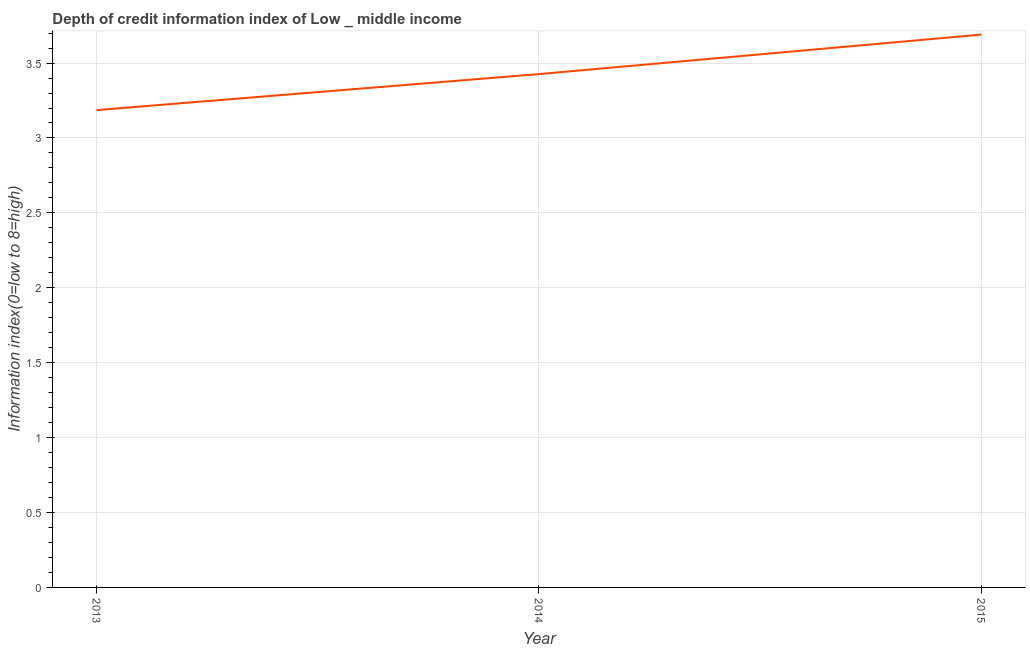What is the depth of credit information index in 2013?
Your answer should be compact. 3.19. Across all years, what is the maximum depth of credit information index?
Offer a very short reply. 3.69. Across all years, what is the minimum depth of credit information index?
Offer a very short reply. 3.19. In which year was the depth of credit information index maximum?
Offer a very short reply. 2015. What is the sum of the depth of credit information index?
Offer a very short reply. 10.3. What is the difference between the depth of credit information index in 2013 and 2015?
Offer a terse response. -0.5. What is the average depth of credit information index per year?
Give a very brief answer. 3.43. What is the median depth of credit information index?
Provide a short and direct response. 3.43. In how many years, is the depth of credit information index greater than 3.4 ?
Provide a short and direct response. 2. What is the ratio of the depth of credit information index in 2013 to that in 2014?
Your answer should be very brief. 0.93. Is the depth of credit information index in 2013 less than that in 2015?
Provide a short and direct response. Yes. What is the difference between the highest and the second highest depth of credit information index?
Offer a terse response. 0.26. What is the difference between the highest and the lowest depth of credit information index?
Provide a short and direct response. 0.5. In how many years, is the depth of credit information index greater than the average depth of credit information index taken over all years?
Provide a short and direct response. 1. What is the difference between two consecutive major ticks on the Y-axis?
Ensure brevity in your answer.  0.5. Are the values on the major ticks of Y-axis written in scientific E-notation?
Provide a succinct answer. No. Does the graph contain any zero values?
Offer a very short reply. No. Does the graph contain grids?
Your response must be concise. Yes. What is the title of the graph?
Your response must be concise. Depth of credit information index of Low _ middle income. What is the label or title of the X-axis?
Provide a succinct answer. Year. What is the label or title of the Y-axis?
Ensure brevity in your answer.  Information index(0=low to 8=high). What is the Information index(0=low to 8=high) of 2013?
Keep it short and to the point. 3.19. What is the Information index(0=low to 8=high) in 2014?
Give a very brief answer. 3.43. What is the Information index(0=low to 8=high) of 2015?
Provide a short and direct response. 3.69. What is the difference between the Information index(0=low to 8=high) in 2013 and 2014?
Keep it short and to the point. -0.24. What is the difference between the Information index(0=low to 8=high) in 2013 and 2015?
Keep it short and to the point. -0.5. What is the difference between the Information index(0=low to 8=high) in 2014 and 2015?
Your answer should be very brief. -0.26. What is the ratio of the Information index(0=low to 8=high) in 2013 to that in 2015?
Make the answer very short. 0.86. What is the ratio of the Information index(0=low to 8=high) in 2014 to that in 2015?
Keep it short and to the point. 0.93. 